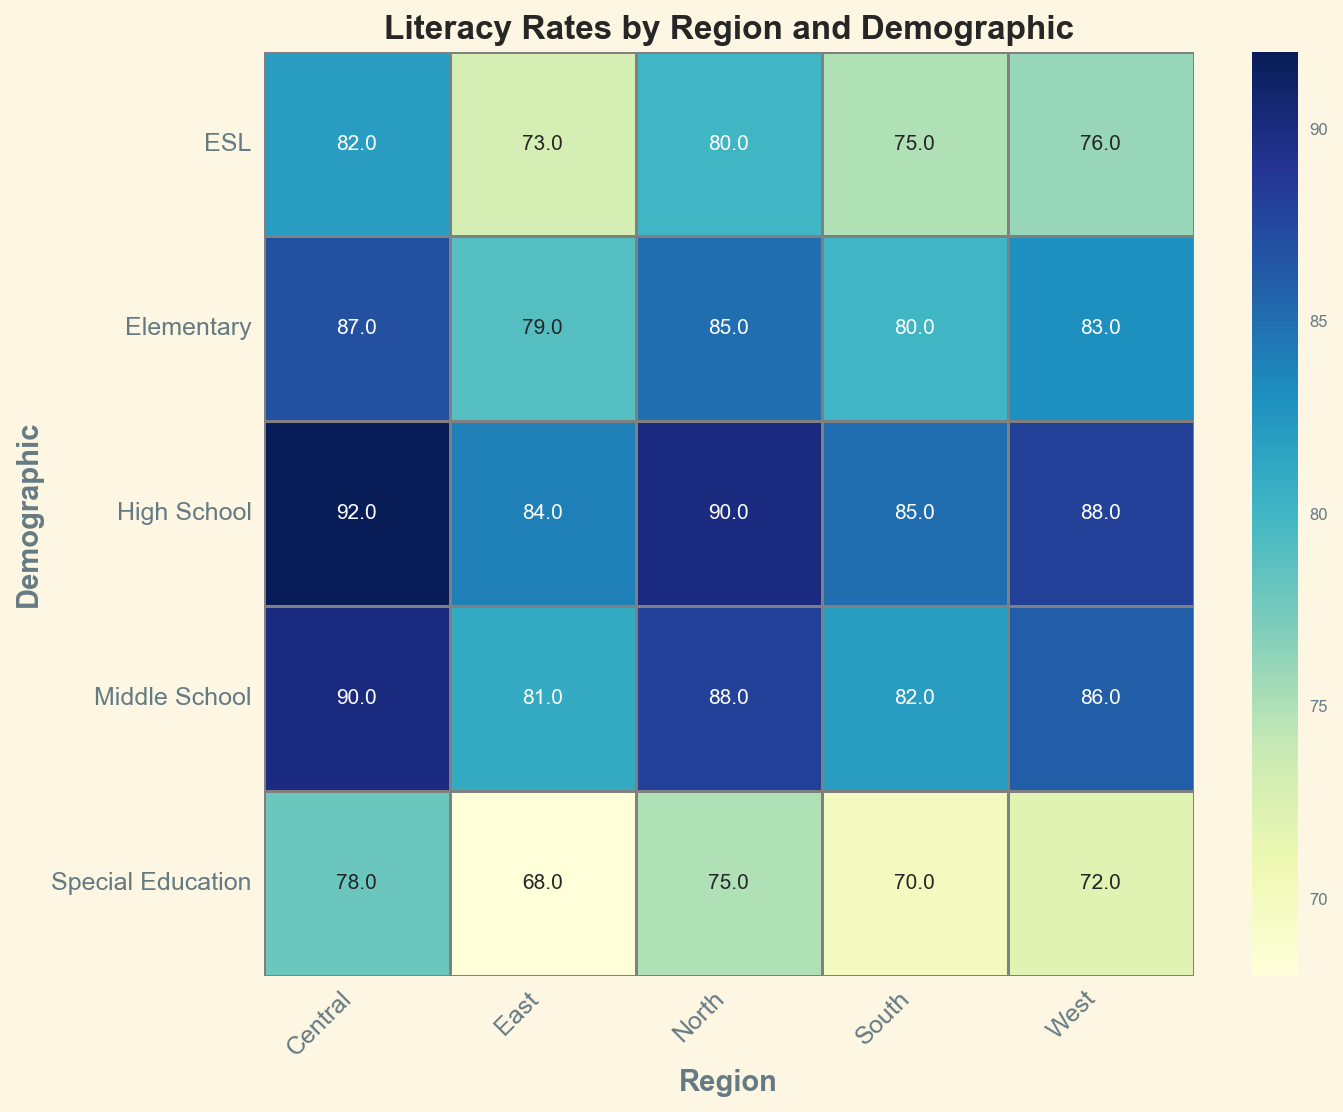Which region has the highest literacy rate for High School students? To find the highest literacy rate for High School students, look at the column under 'High School' and compare the values across all regions. Central region has the highest rate with 92.
Answer: Central Which region has the lowest literacy rate for Elementary students? To find the lowest literacy rate for Elementary students, check the 'Elementary' row and compare the values across all regions. East region has the lowest rate with 79.
Answer: East How does the literacy rate for Special Education students in the South compare to those in the East? Check the 'Special Education' row for the South (70) and East (68) regions. The literacy rate in the South is slightly higher than in the East by 2 points.
Answer: South has higher rates What is the average literacy rate across all demographics in the North region? To find the average literacy rate in the North region, sum the literacy rates for all demographics (85 + 88 + 90 + 75 + 80) = 418 and divide by the number of demographics (5). The average is 418/5 = 83.6.
Answer: 83.6 Which demographic shows the most significant variation in literacy rates across different regions? Look at the rows and check for significant variations in color shades (which indicate different values). 'Special Education' shows the most variation, ranging from 68 in the East to 78 in the Central.
Answer: Special Education In the West region, which demographic has the closest literacy rate to 76? Look at the values in the West column. ESL has a literacy rate of 76, matching the query exactly.
Answer: ESL What is the difference in literacy rates between the highest and lowest literacy demographics in the Central region? Check the values in the Central column. The highest is High School (92) and the lowest is Special Education (78). The difference is 92 - 78 = 14.
Answer: 14 Is the literacy rate for Middle School students higher in the North or Central region? Compare the 'Middle School' row values in the North (88) and Central (90) regions. The Central region has a higher literacy rate by 2 points.
Answer: Central What is the literacy rate range for Elementary students across all regions? Identify the highest and lowest values in the 'Elementary' row. The highest is Central (87) and the lowest is East (79). The range is 87 - 79 = 8.
Answer: 8 How does the central region's elementary literacy rate compare visually to the typical literacy rates for elementary demographics across other regions? The central region's elementary literacy rate (87) appears visually as the lightest shade in the 'Elementary' row, indicating it has one of the highest literacy rates when compared to other regions in the same row.
Answer: Highest 